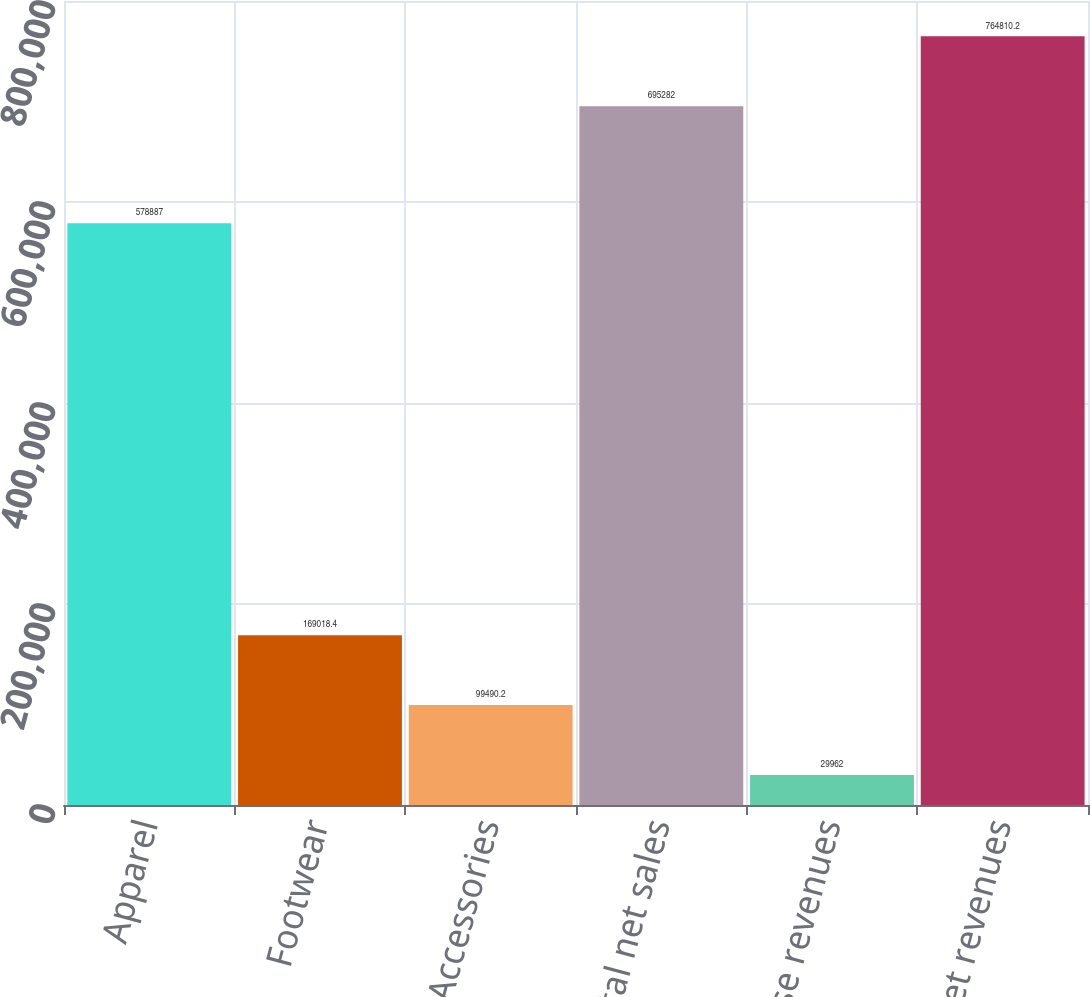<chart> <loc_0><loc_0><loc_500><loc_500><bar_chart><fcel>Apparel<fcel>Footwear<fcel>Accessories<fcel>Total net sales<fcel>License revenues<fcel>Total net revenues<nl><fcel>578887<fcel>169018<fcel>99490.2<fcel>695282<fcel>29962<fcel>764810<nl></chart> 